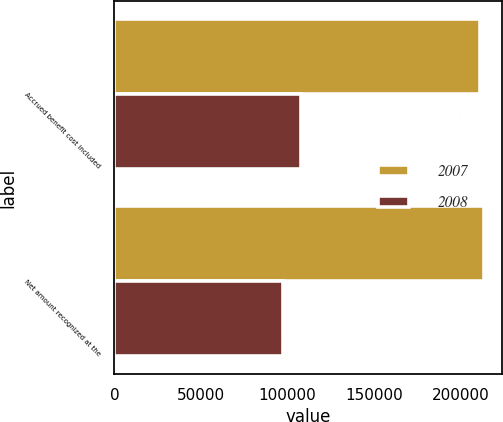<chart> <loc_0><loc_0><loc_500><loc_500><stacked_bar_chart><ecel><fcel>Accrued benefit cost included<fcel>Net amount recognized at the<nl><fcel>2007<fcel>211543<fcel>213466<nl><fcel>2008<fcel>108063<fcel>97280<nl></chart> 